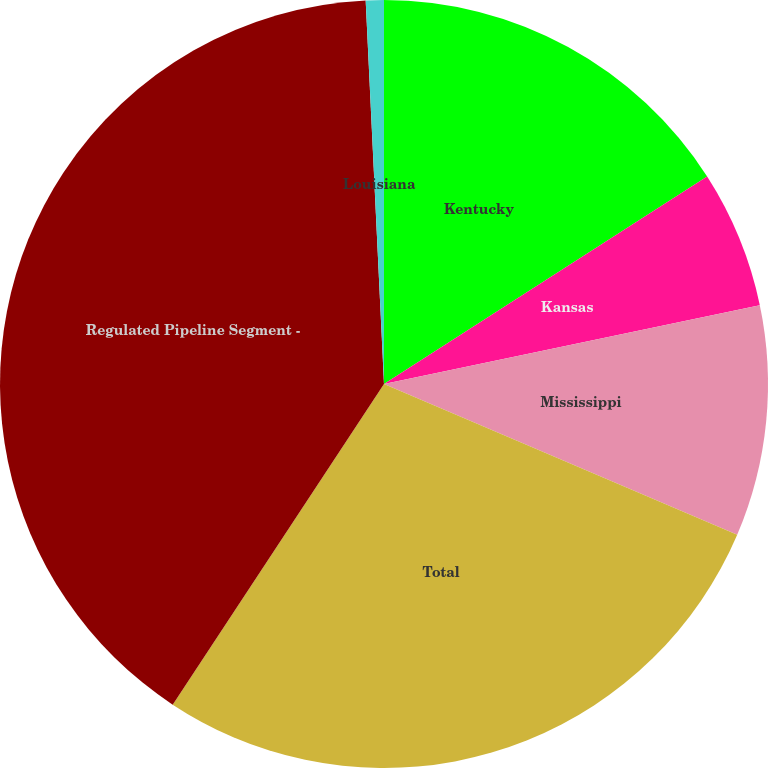<chart> <loc_0><loc_0><loc_500><loc_500><pie_chart><fcel>Kentucky<fcel>Kansas<fcel>Mississippi<fcel>Total<fcel>Regulated Pipeline Segment -<fcel>Louisiana<nl><fcel>15.92%<fcel>5.79%<fcel>9.71%<fcel>27.86%<fcel>39.97%<fcel>0.76%<nl></chart> 